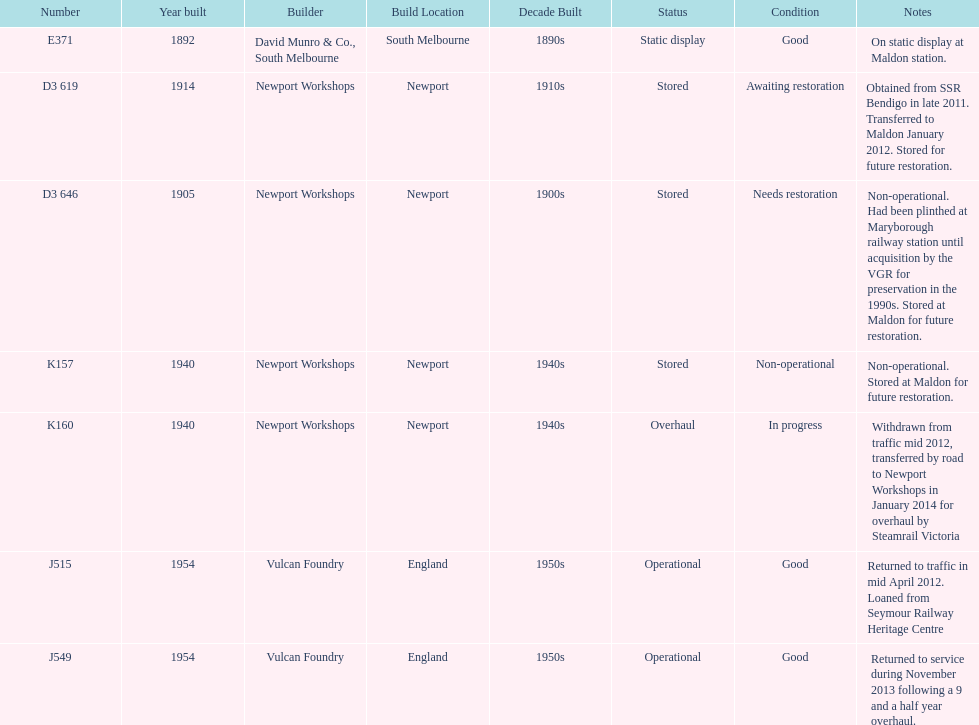Could you help me parse every detail presented in this table? {'header': ['Number', 'Year built', 'Builder', 'Build Location', 'Decade Built', 'Status', 'Condition', 'Notes'], 'rows': [['E371', '1892', 'David Munro & Co., South Melbourne', 'South Melbourne', '1890s', 'Static display', 'Good', 'On static display at Maldon station.'], ['D3 619', '1914', 'Newport Workshops', 'Newport', '1910s', 'Stored', 'Awaiting restoration', 'Obtained from SSR Bendigo in late 2011. Transferred to Maldon January 2012. Stored for future restoration.'], ['D3 646', '1905', 'Newport Workshops', 'Newport', '1900s', 'Stored', 'Needs restoration', 'Non-operational. Had been plinthed at Maryborough railway station until acquisition by the VGR for preservation in the 1990s. Stored at Maldon for future restoration.'], ['K157', '1940', 'Newport Workshops', 'Newport', '1940s', 'Stored', 'Non-operational', 'Non-operational. Stored at Maldon for future restoration.'], ['K160', '1940', 'Newport Workshops', 'Newport', '1940s', 'Overhaul', 'In progress', 'Withdrawn from traffic mid 2012, transferred by road to Newport Workshops in January 2014 for overhaul by Steamrail Victoria'], ['J515', '1954', 'Vulcan Foundry', 'England', '1950s', 'Operational', 'Good', 'Returned to traffic in mid April 2012. Loaned from Seymour Railway Heritage Centre'], ['J549', '1954', 'Vulcan Foundry', 'England', '1950s', 'Operational', 'Good', 'Returned to service during November 2013 following a 9 and a half year overhaul.']]} Which are the only trains still in service? J515, J549. 